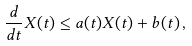<formula> <loc_0><loc_0><loc_500><loc_500>\frac { d } { d t } X ( t ) \leq a ( t ) X ( t ) + b ( t ) \, ,</formula> 